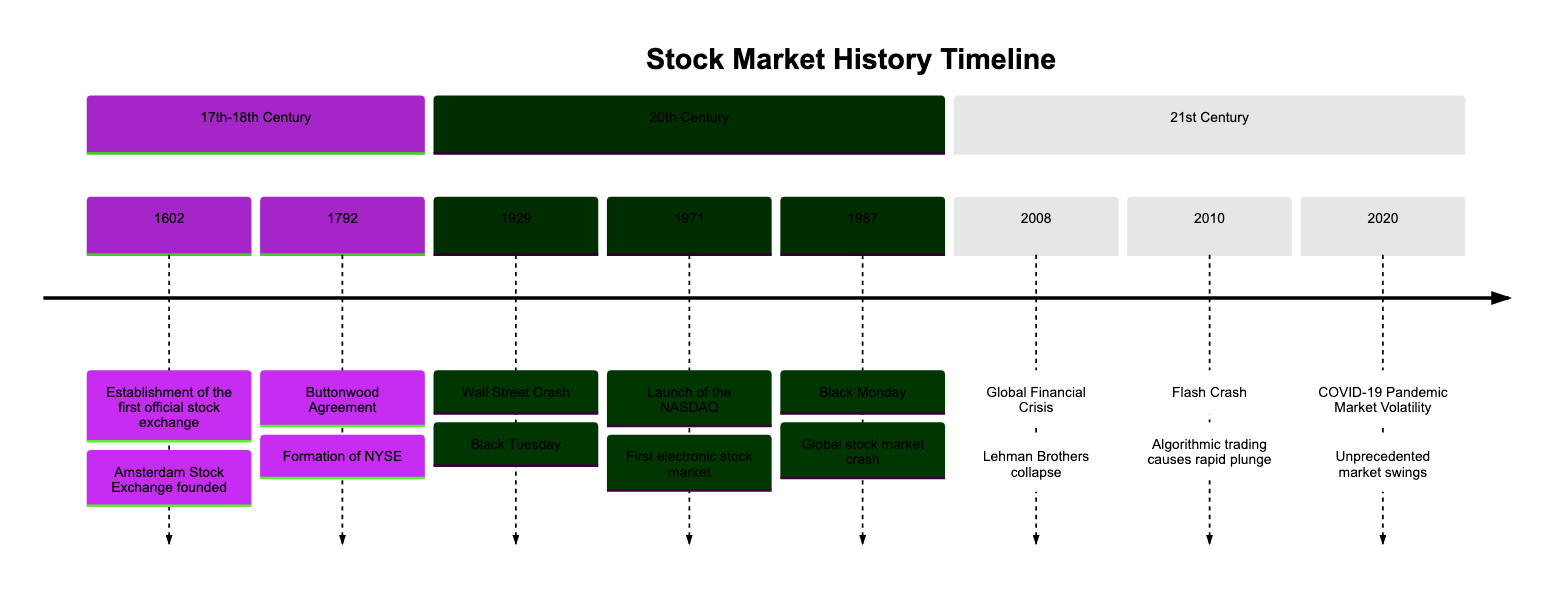What year was the Buttonwood Agreement signed? The Buttonwood Agreement was signed in 1792, as indicated in the timeline section for the 17th-18th Century.
Answer: 1792 What is the event associated with the year 2008? In the year 2008, the event listed is the Global Financial Crisis, which resulted from the collapse of Lehman Brothers.
Answer: Global Financial Crisis How many significant events are before the year 2000? Counting the events listed in the timeline, there are five significant events before the year 2000: 1602, 1792, 1929, 1971, and 1987.
Answer: 5 What was the market impact of the Wall Street Crash of 1929? The Wall Street Crash of 1929, marked as Black Tuesday, caused the Dow Jones Industrial Average to plunge 25% in just two days, reflecting significant market impact.
Answer: 25% What event occurred immediately after the NASDAQ launch? Following the NASDAQ launch in 1971, the next significant event listed is the stock market crash known as Black Monday in 1987.
Answer: Black Monday Which major market event happened in 2010? The major market event that occurred in 2010 is the Flash Crash, characterized by a rapid plunge and recovery in the stock market.
Answer: Flash Crash What was the percentage drop of the Dow Jones on Black Monday? On Black Monday, the Dow Jones Industrial Average fell over 22% in a single day, which illustrates the severity of the crash.
Answer: 22% Which event is described as resulting in unprecedented market volatility during 2020? In 2020, the event associated with unprecedented market volatility is the COVID-19 Pandemic Market Volatility, affecting major indices like the S&P 500.
Answer: COVID-19 Pandemic Market Volatility 